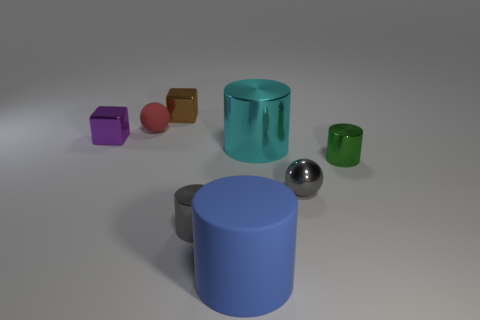Add 1 small red matte objects. How many objects exist? 9 Subtract all cubes. How many objects are left? 6 Add 2 cyan shiny blocks. How many cyan shiny blocks exist? 2 Subtract 1 blue cylinders. How many objects are left? 7 Subtract all large red shiny things. Subtract all matte things. How many objects are left? 6 Add 1 purple shiny cubes. How many purple shiny cubes are left? 2 